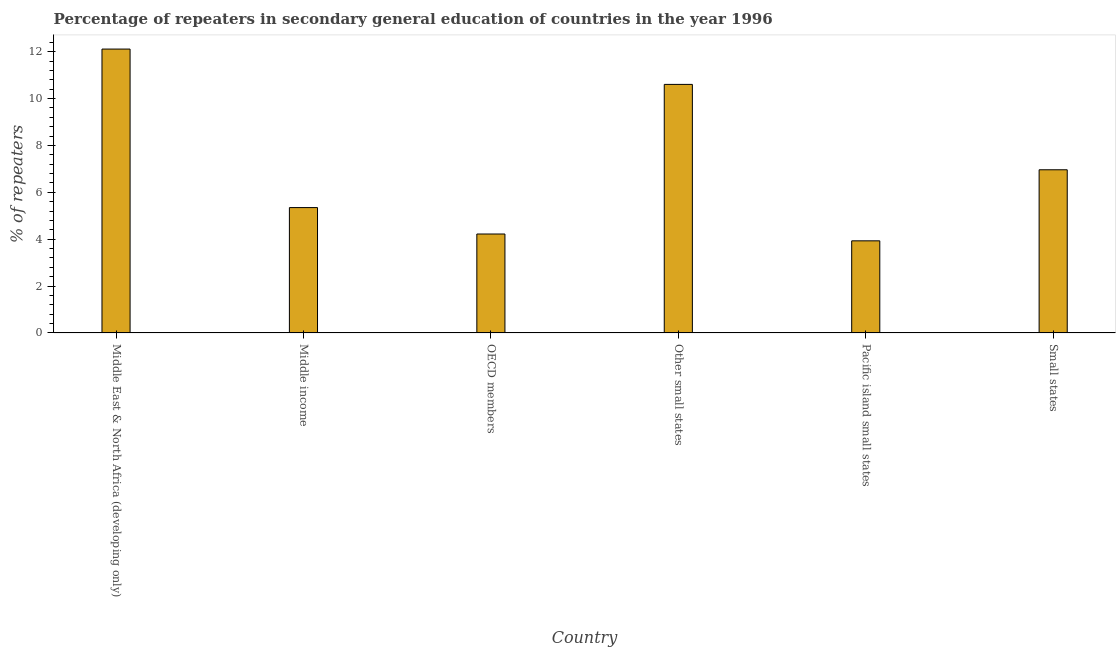What is the title of the graph?
Give a very brief answer. Percentage of repeaters in secondary general education of countries in the year 1996. What is the label or title of the Y-axis?
Offer a terse response. % of repeaters. What is the percentage of repeaters in OECD members?
Ensure brevity in your answer.  4.22. Across all countries, what is the maximum percentage of repeaters?
Offer a very short reply. 12.11. Across all countries, what is the minimum percentage of repeaters?
Offer a very short reply. 3.93. In which country was the percentage of repeaters maximum?
Offer a very short reply. Middle East & North Africa (developing only). In which country was the percentage of repeaters minimum?
Your answer should be very brief. Pacific island small states. What is the sum of the percentage of repeaters?
Provide a short and direct response. 43.18. What is the difference between the percentage of repeaters in Middle income and Small states?
Give a very brief answer. -1.61. What is the average percentage of repeaters per country?
Your answer should be very brief. 7.2. What is the median percentage of repeaters?
Provide a succinct answer. 6.16. In how many countries, is the percentage of repeaters greater than 11.2 %?
Give a very brief answer. 1. What is the ratio of the percentage of repeaters in Middle East & North Africa (developing only) to that in Middle income?
Provide a succinct answer. 2.26. Is the percentage of repeaters in Middle East & North Africa (developing only) less than that in OECD members?
Provide a succinct answer. No. Is the difference between the percentage of repeaters in Middle income and Other small states greater than the difference between any two countries?
Offer a very short reply. No. What is the difference between the highest and the second highest percentage of repeaters?
Give a very brief answer. 1.51. What is the difference between the highest and the lowest percentage of repeaters?
Your answer should be very brief. 8.18. Are the values on the major ticks of Y-axis written in scientific E-notation?
Make the answer very short. No. What is the % of repeaters in Middle East & North Africa (developing only)?
Ensure brevity in your answer.  12.11. What is the % of repeaters of Middle income?
Make the answer very short. 5.35. What is the % of repeaters in OECD members?
Your answer should be very brief. 4.22. What is the % of repeaters in Other small states?
Make the answer very short. 10.61. What is the % of repeaters of Pacific island small states?
Ensure brevity in your answer.  3.93. What is the % of repeaters in Small states?
Offer a terse response. 6.96. What is the difference between the % of repeaters in Middle East & North Africa (developing only) and Middle income?
Your response must be concise. 6.76. What is the difference between the % of repeaters in Middle East & North Africa (developing only) and OECD members?
Your response must be concise. 7.89. What is the difference between the % of repeaters in Middle East & North Africa (developing only) and Other small states?
Provide a short and direct response. 1.51. What is the difference between the % of repeaters in Middle East & North Africa (developing only) and Pacific island small states?
Provide a succinct answer. 8.18. What is the difference between the % of repeaters in Middle East & North Africa (developing only) and Small states?
Your answer should be compact. 5.15. What is the difference between the % of repeaters in Middle income and OECD members?
Your response must be concise. 1.13. What is the difference between the % of repeaters in Middle income and Other small states?
Keep it short and to the point. -5.26. What is the difference between the % of repeaters in Middle income and Pacific island small states?
Make the answer very short. 1.42. What is the difference between the % of repeaters in Middle income and Small states?
Make the answer very short. -1.61. What is the difference between the % of repeaters in OECD members and Other small states?
Give a very brief answer. -6.38. What is the difference between the % of repeaters in OECD members and Pacific island small states?
Your answer should be very brief. 0.29. What is the difference between the % of repeaters in OECD members and Small states?
Offer a terse response. -2.74. What is the difference between the % of repeaters in Other small states and Pacific island small states?
Offer a terse response. 6.68. What is the difference between the % of repeaters in Other small states and Small states?
Provide a succinct answer. 3.64. What is the difference between the % of repeaters in Pacific island small states and Small states?
Offer a very short reply. -3.03. What is the ratio of the % of repeaters in Middle East & North Africa (developing only) to that in Middle income?
Make the answer very short. 2.26. What is the ratio of the % of repeaters in Middle East & North Africa (developing only) to that in OECD members?
Offer a terse response. 2.87. What is the ratio of the % of repeaters in Middle East & North Africa (developing only) to that in Other small states?
Your response must be concise. 1.14. What is the ratio of the % of repeaters in Middle East & North Africa (developing only) to that in Pacific island small states?
Keep it short and to the point. 3.08. What is the ratio of the % of repeaters in Middle East & North Africa (developing only) to that in Small states?
Ensure brevity in your answer.  1.74. What is the ratio of the % of repeaters in Middle income to that in OECD members?
Give a very brief answer. 1.27. What is the ratio of the % of repeaters in Middle income to that in Other small states?
Make the answer very short. 0.5. What is the ratio of the % of repeaters in Middle income to that in Pacific island small states?
Ensure brevity in your answer.  1.36. What is the ratio of the % of repeaters in Middle income to that in Small states?
Your answer should be very brief. 0.77. What is the ratio of the % of repeaters in OECD members to that in Other small states?
Provide a succinct answer. 0.4. What is the ratio of the % of repeaters in OECD members to that in Pacific island small states?
Ensure brevity in your answer.  1.07. What is the ratio of the % of repeaters in OECD members to that in Small states?
Keep it short and to the point. 0.61. What is the ratio of the % of repeaters in Other small states to that in Pacific island small states?
Ensure brevity in your answer.  2.7. What is the ratio of the % of repeaters in Other small states to that in Small states?
Your response must be concise. 1.52. What is the ratio of the % of repeaters in Pacific island small states to that in Small states?
Give a very brief answer. 0.56. 